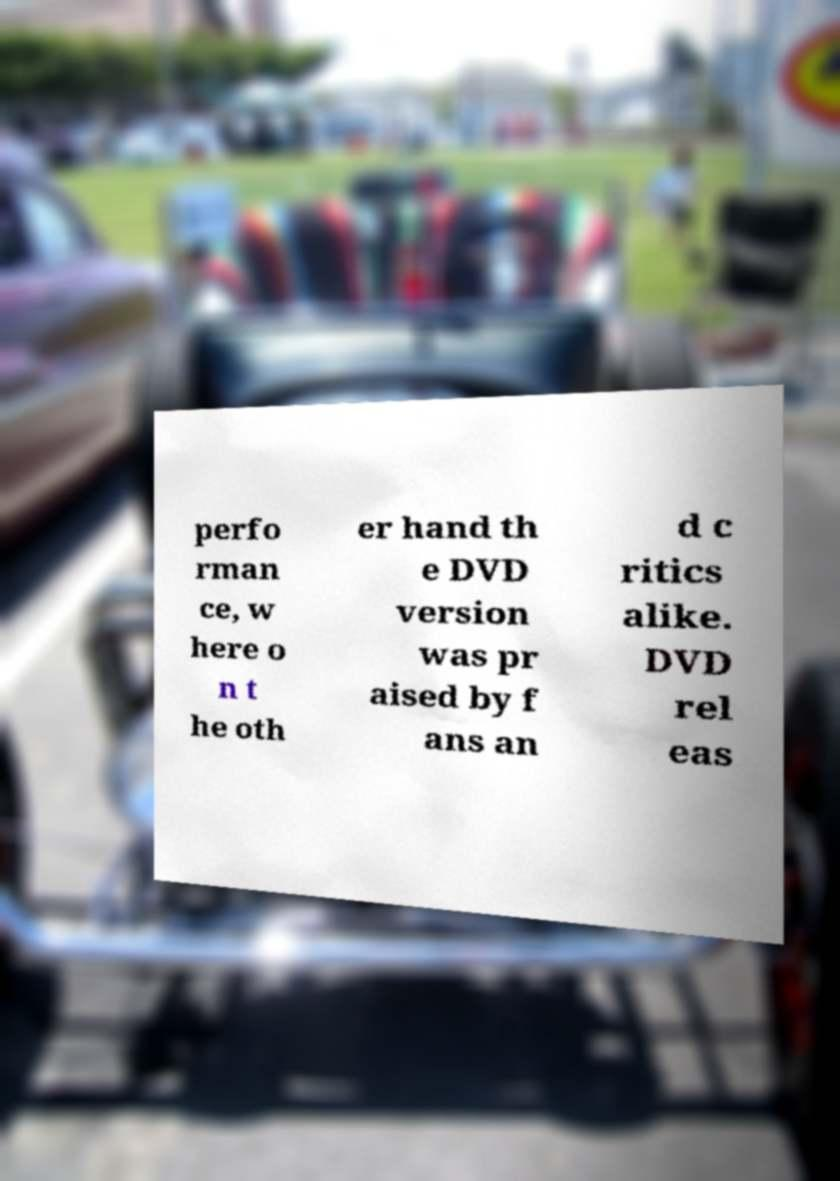I need the written content from this picture converted into text. Can you do that? perfo rman ce, w here o n t he oth er hand th e DVD version was pr aised by f ans an d c ritics alike. DVD rel eas 